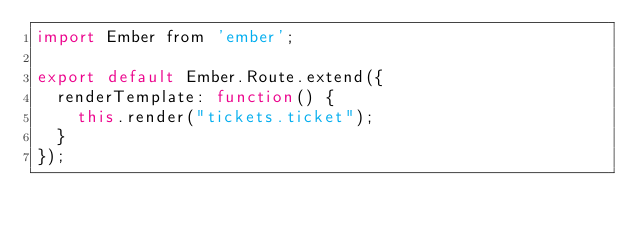<code> <loc_0><loc_0><loc_500><loc_500><_JavaScript_>import Ember from 'ember';

export default Ember.Route.extend({
	renderTemplate: function() {
		this.render("tickets.ticket");
	}
});</code> 